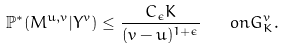<formula> <loc_0><loc_0><loc_500><loc_500>\mathbb { P } ^ { \ast } ( M ^ { u , v } | Y ^ { v } ) \leq \frac { C _ { \epsilon } K } { ( v - u ) ^ { 1 + \epsilon } } \quad o n G _ { K } ^ { v } .</formula> 